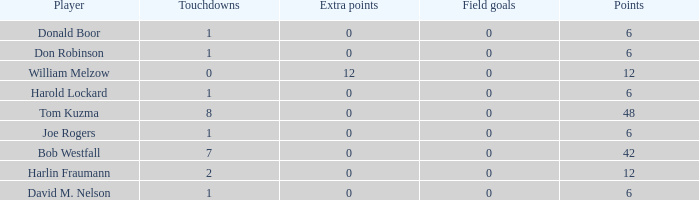Name the least touchdowns for joe rogers 1.0. 